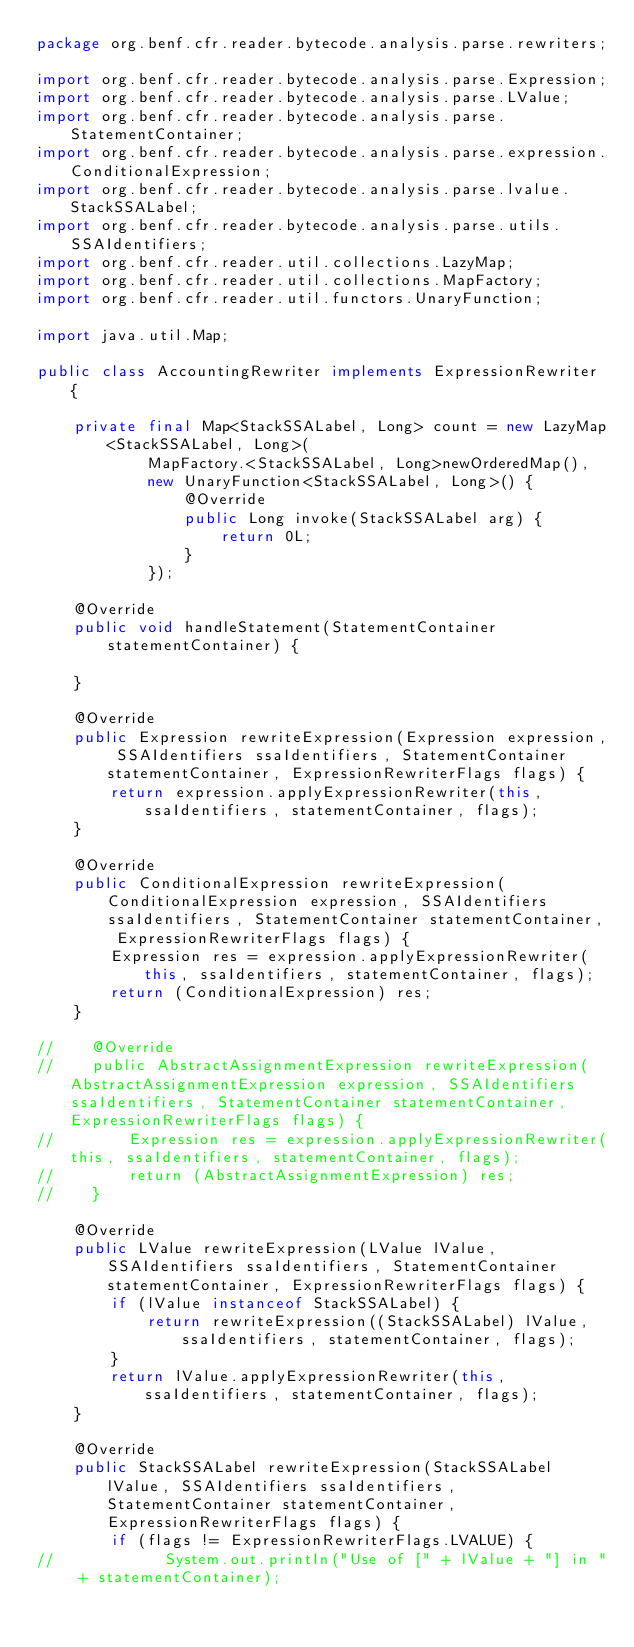<code> <loc_0><loc_0><loc_500><loc_500><_Java_>package org.benf.cfr.reader.bytecode.analysis.parse.rewriters;

import org.benf.cfr.reader.bytecode.analysis.parse.Expression;
import org.benf.cfr.reader.bytecode.analysis.parse.LValue;
import org.benf.cfr.reader.bytecode.analysis.parse.StatementContainer;
import org.benf.cfr.reader.bytecode.analysis.parse.expression.ConditionalExpression;
import org.benf.cfr.reader.bytecode.analysis.parse.lvalue.StackSSALabel;
import org.benf.cfr.reader.bytecode.analysis.parse.utils.SSAIdentifiers;
import org.benf.cfr.reader.util.collections.LazyMap;
import org.benf.cfr.reader.util.collections.MapFactory;
import org.benf.cfr.reader.util.functors.UnaryFunction;

import java.util.Map;

public class AccountingRewriter implements ExpressionRewriter {

    private final Map<StackSSALabel, Long> count = new LazyMap<StackSSALabel, Long>(
            MapFactory.<StackSSALabel, Long>newOrderedMap(),
            new UnaryFunction<StackSSALabel, Long>() {
                @Override
                public Long invoke(StackSSALabel arg) {
                    return 0L;
                }
            });

    @Override
    public void handleStatement(StatementContainer statementContainer) {

    }

    @Override
    public Expression rewriteExpression(Expression expression, SSAIdentifiers ssaIdentifiers, StatementContainer statementContainer, ExpressionRewriterFlags flags) {
        return expression.applyExpressionRewriter(this, ssaIdentifiers, statementContainer, flags);
    }

    @Override
    public ConditionalExpression rewriteExpression(ConditionalExpression expression, SSAIdentifiers ssaIdentifiers, StatementContainer statementContainer, ExpressionRewriterFlags flags) {
        Expression res = expression.applyExpressionRewriter(this, ssaIdentifiers, statementContainer, flags);
        return (ConditionalExpression) res;
    }

//    @Override
//    public AbstractAssignmentExpression rewriteExpression(AbstractAssignmentExpression expression, SSAIdentifiers ssaIdentifiers, StatementContainer statementContainer, ExpressionRewriterFlags flags) {
//        Expression res = expression.applyExpressionRewriter(this, ssaIdentifiers, statementContainer, flags);
//        return (AbstractAssignmentExpression) res;
//    }

    @Override
    public LValue rewriteExpression(LValue lValue, SSAIdentifiers ssaIdentifiers, StatementContainer statementContainer, ExpressionRewriterFlags flags) {
        if (lValue instanceof StackSSALabel) {
            return rewriteExpression((StackSSALabel) lValue, ssaIdentifiers, statementContainer, flags);
        }
        return lValue.applyExpressionRewriter(this, ssaIdentifiers, statementContainer, flags);
    }

    @Override
    public StackSSALabel rewriteExpression(StackSSALabel lValue, SSAIdentifiers ssaIdentifiers, StatementContainer statementContainer, ExpressionRewriterFlags flags) {
        if (flags != ExpressionRewriterFlags.LVALUE) {
//            System.out.println("Use of [" + lValue + "] in " + statementContainer);</code> 